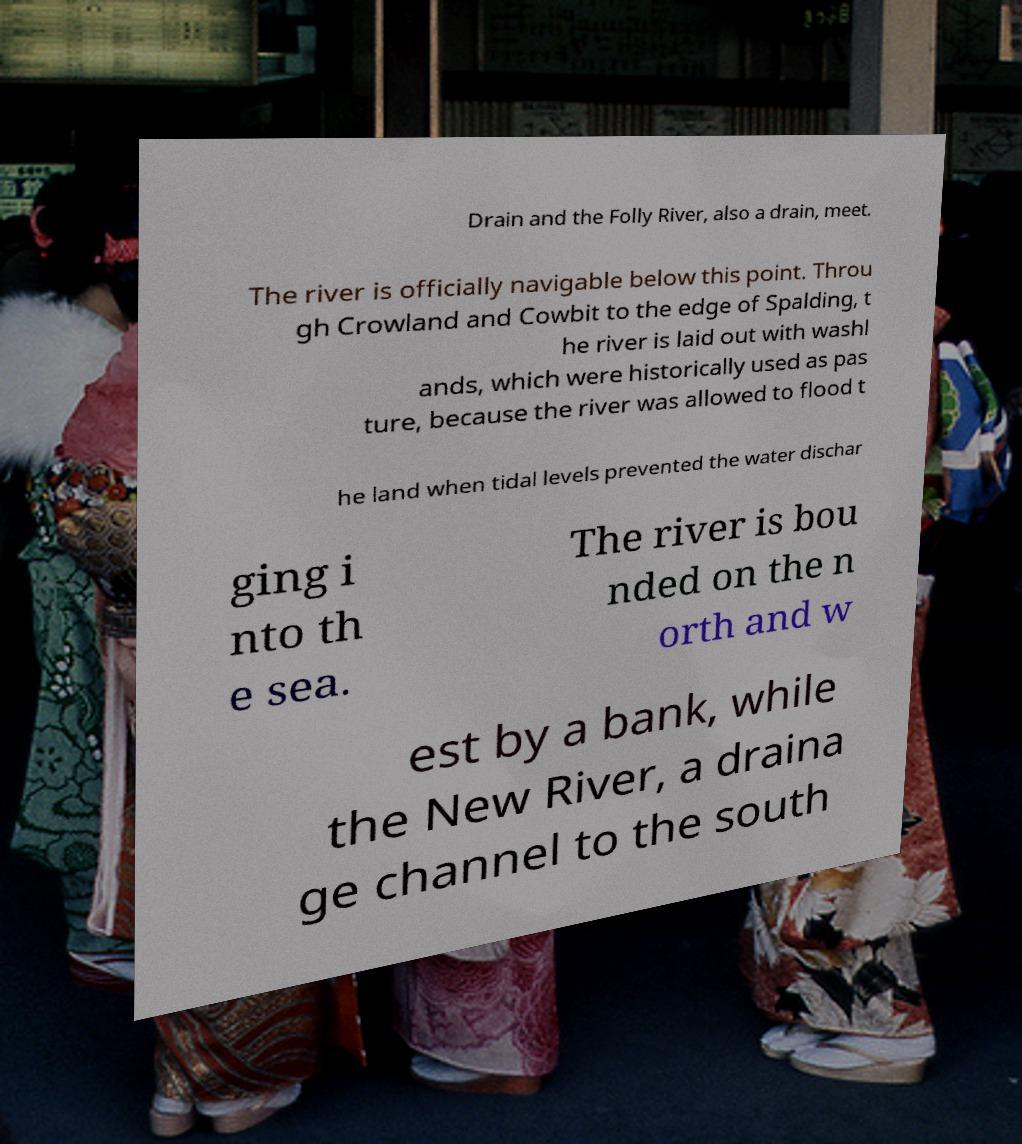What messages or text are displayed in this image? I need them in a readable, typed format. Drain and the Folly River, also a drain, meet. The river is officially navigable below this point. Throu gh Crowland and Cowbit to the edge of Spalding, t he river is laid out with washl ands, which were historically used as pas ture, because the river was allowed to flood t he land when tidal levels prevented the water dischar ging i nto th e sea. The river is bou nded on the n orth and w est by a bank, while the New River, a draina ge channel to the south 